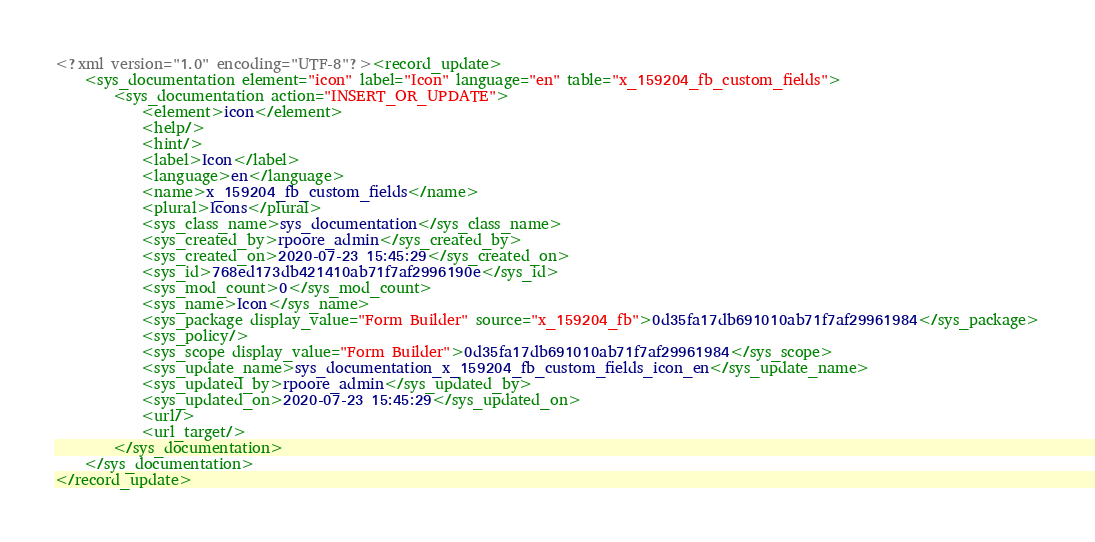Convert code to text. <code><loc_0><loc_0><loc_500><loc_500><_XML_><?xml version="1.0" encoding="UTF-8"?><record_update>
    <sys_documentation element="icon" label="Icon" language="en" table="x_159204_fb_custom_fields">
        <sys_documentation action="INSERT_OR_UPDATE">
            <element>icon</element>
            <help/>
            <hint/>
            <label>Icon</label>
            <language>en</language>
            <name>x_159204_fb_custom_fields</name>
            <plural>Icons</plural>
            <sys_class_name>sys_documentation</sys_class_name>
            <sys_created_by>rpoore_admin</sys_created_by>
            <sys_created_on>2020-07-23 15:45:29</sys_created_on>
            <sys_id>768ed173db421410ab71f7af2996190e</sys_id>
            <sys_mod_count>0</sys_mod_count>
            <sys_name>Icon</sys_name>
            <sys_package display_value="Form Builder" source="x_159204_fb">0d35fa17db691010ab71f7af29961984</sys_package>
            <sys_policy/>
            <sys_scope display_value="Form Builder">0d35fa17db691010ab71f7af29961984</sys_scope>
            <sys_update_name>sys_documentation_x_159204_fb_custom_fields_icon_en</sys_update_name>
            <sys_updated_by>rpoore_admin</sys_updated_by>
            <sys_updated_on>2020-07-23 15:45:29</sys_updated_on>
            <url/>
            <url_target/>
        </sys_documentation>
    </sys_documentation>
</record_update>
</code> 